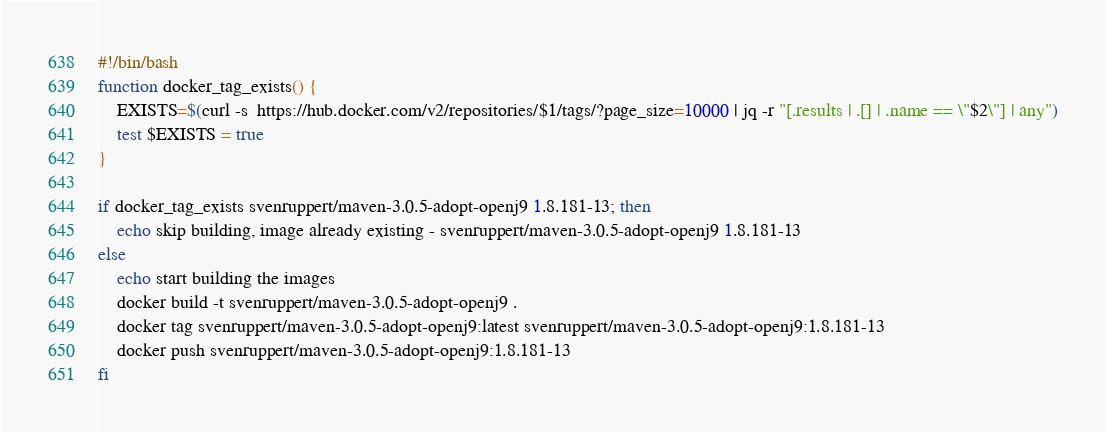<code> <loc_0><loc_0><loc_500><loc_500><_Bash_>#!/bin/bash
function docker_tag_exists() {
    EXISTS=$(curl -s  https://hub.docker.com/v2/repositories/$1/tags/?page_size=10000 | jq -r "[.results | .[] | .name == \"$2\"] | any")
    test $EXISTS = true
}

if docker_tag_exists svenruppert/maven-3.0.5-adopt-openj9 1.8.181-13; then
    echo skip building, image already existing - svenruppert/maven-3.0.5-adopt-openj9 1.8.181-13
else
    echo start building the images
    docker build -t svenruppert/maven-3.0.5-adopt-openj9 .
    docker tag svenruppert/maven-3.0.5-adopt-openj9:latest svenruppert/maven-3.0.5-adopt-openj9:1.8.181-13
    docker push svenruppert/maven-3.0.5-adopt-openj9:1.8.181-13
fi</code> 